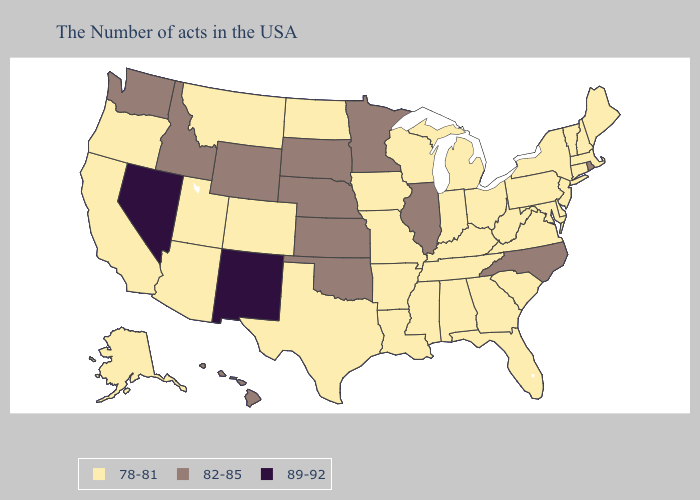Name the states that have a value in the range 82-85?
Short answer required. Rhode Island, North Carolina, Illinois, Minnesota, Kansas, Nebraska, Oklahoma, South Dakota, Wyoming, Idaho, Washington, Hawaii. Does Wyoming have the highest value in the USA?
Write a very short answer. No. Name the states that have a value in the range 89-92?
Short answer required. New Mexico, Nevada. Does the map have missing data?
Concise answer only. No. Does the map have missing data?
Write a very short answer. No. What is the value of Wisconsin?
Be succinct. 78-81. Name the states that have a value in the range 78-81?
Give a very brief answer. Maine, Massachusetts, New Hampshire, Vermont, Connecticut, New York, New Jersey, Delaware, Maryland, Pennsylvania, Virginia, South Carolina, West Virginia, Ohio, Florida, Georgia, Michigan, Kentucky, Indiana, Alabama, Tennessee, Wisconsin, Mississippi, Louisiana, Missouri, Arkansas, Iowa, Texas, North Dakota, Colorado, Utah, Montana, Arizona, California, Oregon, Alaska. Which states have the lowest value in the Northeast?
Give a very brief answer. Maine, Massachusetts, New Hampshire, Vermont, Connecticut, New York, New Jersey, Pennsylvania. What is the highest value in the West ?
Keep it brief. 89-92. What is the value of Kansas?
Be succinct. 82-85. What is the highest value in states that border Colorado?
Give a very brief answer. 89-92. Among the states that border South Dakota , does Iowa have the lowest value?
Write a very short answer. Yes. What is the value of Colorado?
Concise answer only. 78-81. Does Mississippi have a lower value than Maine?
Concise answer only. No. Which states have the highest value in the USA?
Short answer required. New Mexico, Nevada. 